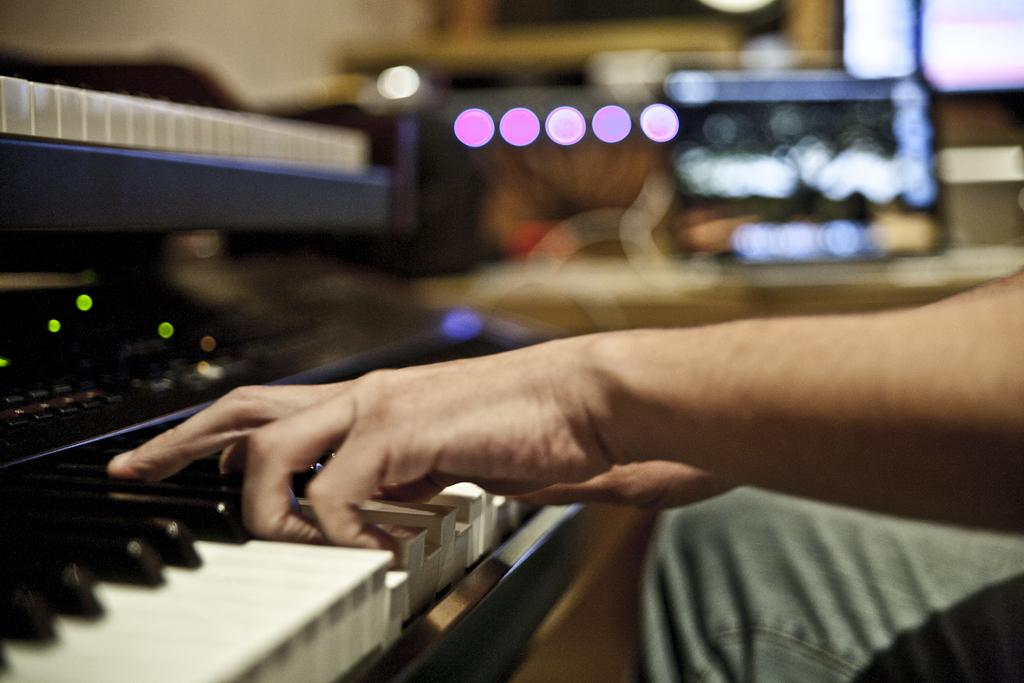What is the person in the image doing? The person is playing the piano in the image. What can be seen in the background of the image? There are lights visible in the background of the image. How would you describe the background of the image? The background is blurry. Where is the lunchroom located in the image? There is no lunchroom present in the image. What type of account is being discussed in the image? There is no account being discussed in the image. 